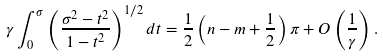<formula> <loc_0><loc_0><loc_500><loc_500>\gamma \int _ { 0 } ^ { \sigma } { \left ( { \frac { \sigma ^ { 2 } - t ^ { 2 } } { 1 - t ^ { 2 } } } \right ) ^ { 1 / 2 } d t } = \frac { 1 } { 2 } \left ( { n - m + \frac { 1 } { 2 } } \right ) \pi + { O } \left ( { \frac { 1 } { \gamma } } \right ) .</formula> 